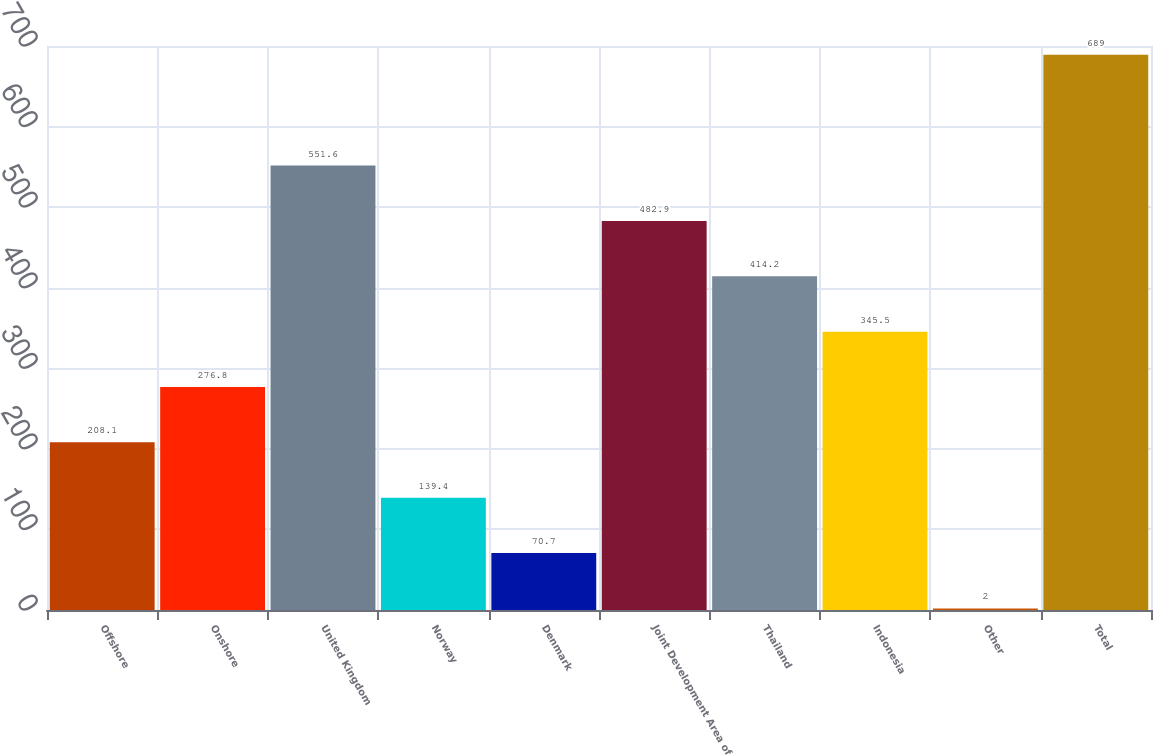<chart> <loc_0><loc_0><loc_500><loc_500><bar_chart><fcel>Offshore<fcel>Onshore<fcel>United Kingdom<fcel>Norway<fcel>Denmark<fcel>Joint Development Area of<fcel>Thailand<fcel>Indonesia<fcel>Other<fcel>Total<nl><fcel>208.1<fcel>276.8<fcel>551.6<fcel>139.4<fcel>70.7<fcel>482.9<fcel>414.2<fcel>345.5<fcel>2<fcel>689<nl></chart> 